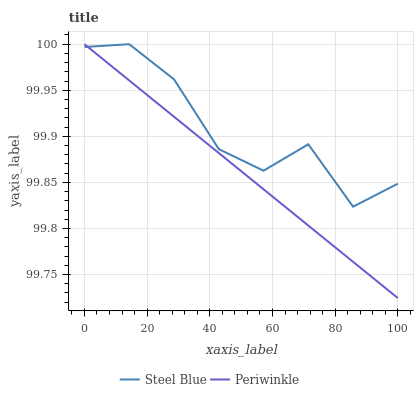Does Periwinkle have the minimum area under the curve?
Answer yes or no. Yes. Does Steel Blue have the maximum area under the curve?
Answer yes or no. Yes. Does Steel Blue have the minimum area under the curve?
Answer yes or no. No. Is Periwinkle the smoothest?
Answer yes or no. Yes. Is Steel Blue the roughest?
Answer yes or no. Yes. Is Steel Blue the smoothest?
Answer yes or no. No. Does Periwinkle have the lowest value?
Answer yes or no. Yes. Does Steel Blue have the lowest value?
Answer yes or no. No. Does Steel Blue have the highest value?
Answer yes or no. Yes. Does Periwinkle intersect Steel Blue?
Answer yes or no. Yes. Is Periwinkle less than Steel Blue?
Answer yes or no. No. Is Periwinkle greater than Steel Blue?
Answer yes or no. No. 